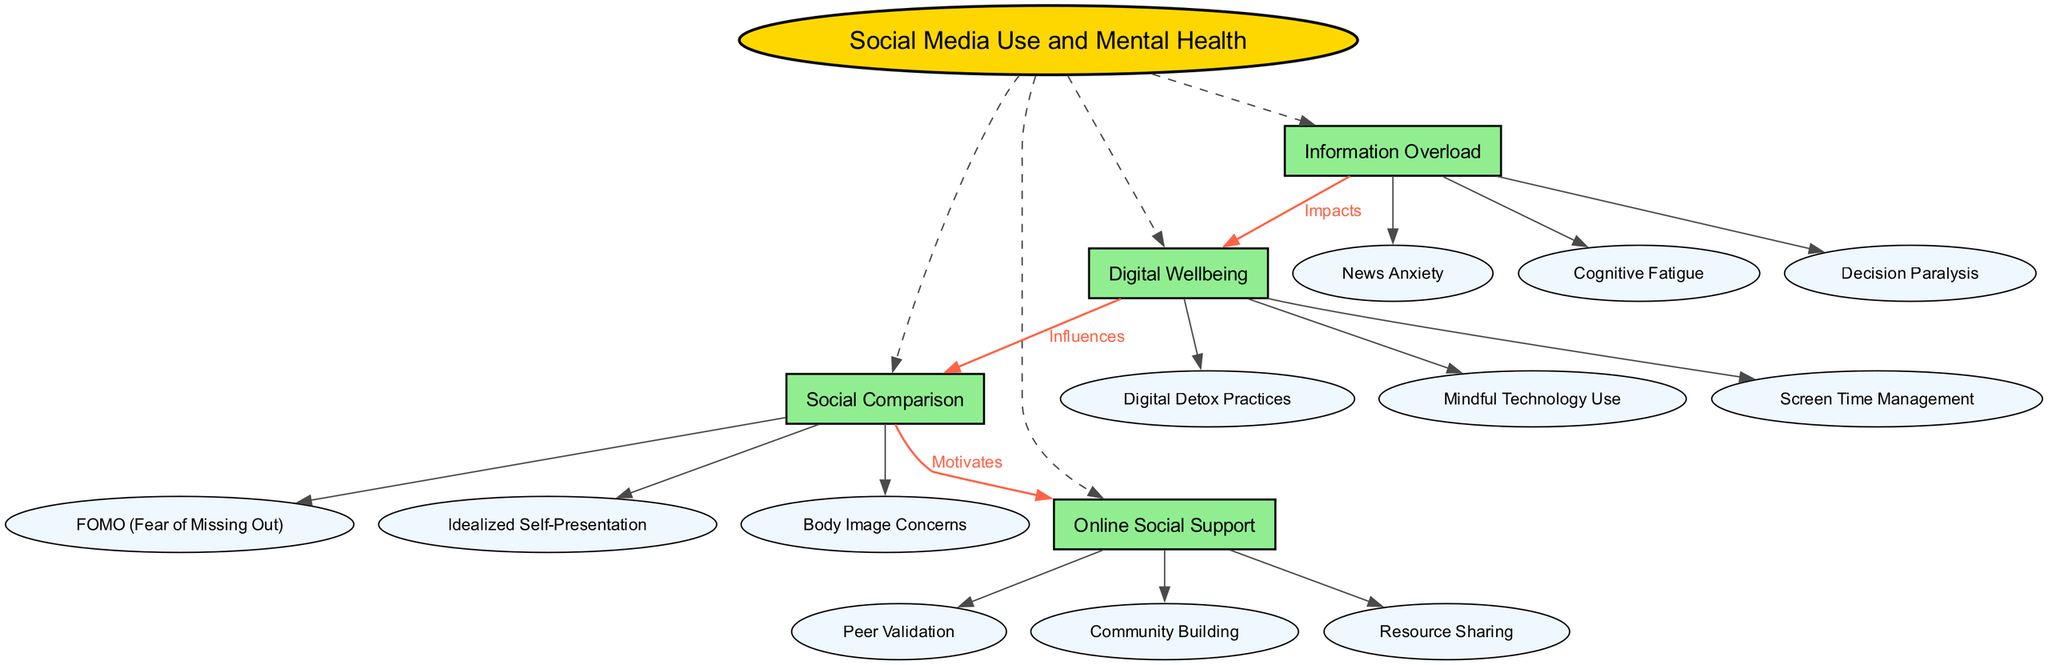What is the central theme of the diagram? The central theme is clearly indicated at the top of the diagram and is represented in a distinct shape and color, differentiating it from the other nodes. The data explicitly states "Social Media Use and Mental Health" as the central theme.
Answer: Social Media Use and Mental Health How many main themes are identified in the diagram? By examining the main themes listed in the diagram, we see there are four distinct themes represented, each with its own node connected to the central theme. Counting these nodes gives us the total number of main themes.
Answer: 4 What are the subthemes of Digital Wellbeing? The subthemes under Digital Wellbeing can be found linked to the main theme node. Three specific subthemes are listed, and their names can be directly read off in the diagram.
Answer: Screen Time Management, Digital Detox Practices, Mindful Technology Use Which theme influences Social Comparison? The connection arrows indicate that one theme directly influences another, which is explicitly labeled. In this case, tracing the arrow from Digital Wellbeing to Social Comparison reveals the influence relationship.
Answer: Digital Wellbeing What motivates Online Social Support? Observing the diagram helps establish the flow of influence between the themes. An arrow from Social Comparison to Online Social Support points to a motivational relationship, as labeled in the diagram.
Answer: Social Comparison How many subthemes are associated with Information Overload? Looking at the node for Information Overload, the subthemes associated with it can be easily counted within the diagram. There are three subthemes listed under this theme.
Answer: 3 What is the label describing the relationship from Information Overload to Digital Wellbeing? The label associated with the connection between these two themes indicates the nature of their relationship. By following the labeled arrow, we can find the specific description provided.
Answer: Impacts Which theme is connected to Peer Validation? By examining the subthemes of Online Social Support, we can see the connection between the theme and specific aspects that relate to it. Peer Validation is identified as a subtheme in this category.
Answer: Online Social Support 